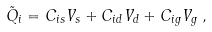Convert formula to latex. <formula><loc_0><loc_0><loc_500><loc_500>\tilde { Q } _ { i } = C _ { i s } V _ { s } + C _ { i d } V _ { d } + C _ { i g } V _ { g } \, ,</formula> 